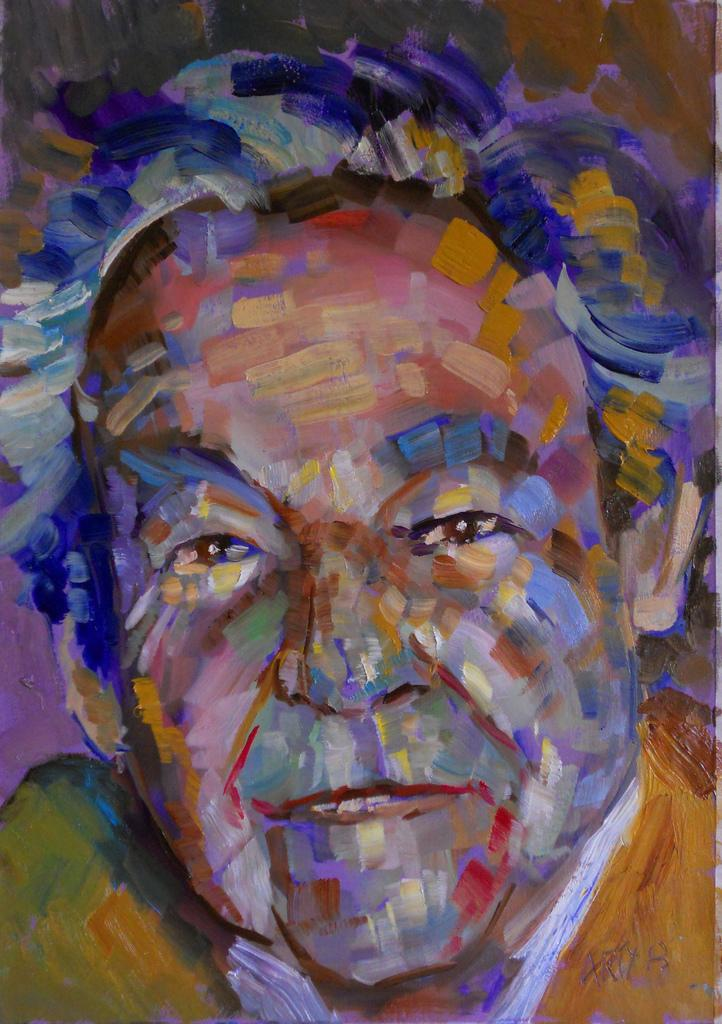What is the main subject of the image? The main subject of the image is an art of a person. Can you describe the person in the art? Unfortunately, the provided facts do not include any details about the person in the art. What is the style or medium of the art? The provided facts do not specify the style or medium of the art. What type of drink is the dog holding in the image? There is no dog or drink present in the image; it features an art of a person. 